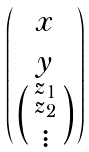<formula> <loc_0><loc_0><loc_500><loc_500>\begin{pmatrix} x \\ y \\ \left ( \begin{smallmatrix} z _ { 1 } \\ z _ { 2 } \\ \vdots \end{smallmatrix} \right ) \end{pmatrix}</formula> 